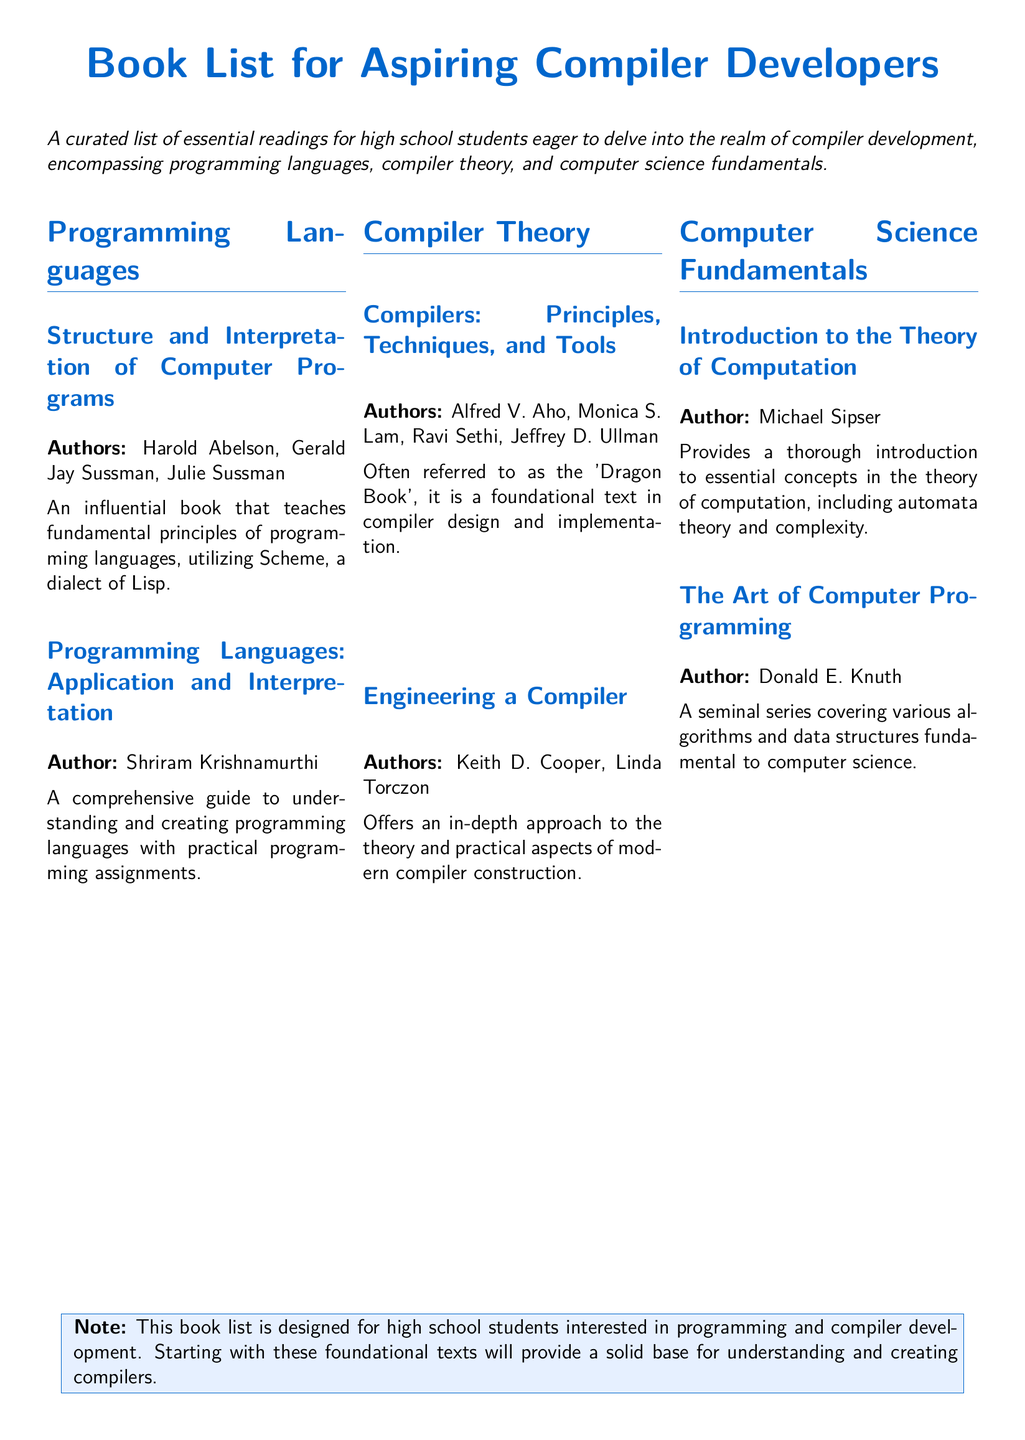What is the title of the book by Harold Abelson? The title of the book is listed under the Programming Languages section, authored by Harold Abelson, and it is "Structure and Interpretation of Computer Programs."
Answer: Structure and Interpretation of Computer Programs Who are the authors of the "Dragon Book"? The authors of the "Dragon Book" are listed under the Compiler Theory section, and they are Alfred V. Aho, Monica S. Lam, Ravi Sethi, and Jeffrey D. Ullman.
Answer: Alfred V. Aho, Monica S. Lam, Ravi Sethi, Jeffrey D. Ullman What is the focus of "Engineering a Compiler"? "Engineering a Compiler" focuses on the theory and practical aspects of modern compiler construction, as stated in its description.
Answer: Theory and practical aspects How many sections are there in the document? The document is divided into three main sections: Programming Languages, Compiler Theory, and Computer Science Fundamentals, making it easy to count the sections.
Answer: Three What is the purpose of this book list? The purpose of the book list is specified in the introductory text describing it as designed for high school students interested in programming and compiler development.
Answer: For high school students Which book covers algorithms and data structures? The book that covers algorithms and data structures is mentioned in the Computer Science Fundamentals section, and it is authored by Donald E. Knuth.
Answer: The Art of Computer Programming What is recommended to start with as a foundation according to the note? The note in the document recommends starting with foundational texts to build a solid base for understanding and creating compilers.
Answer: Foundational texts 